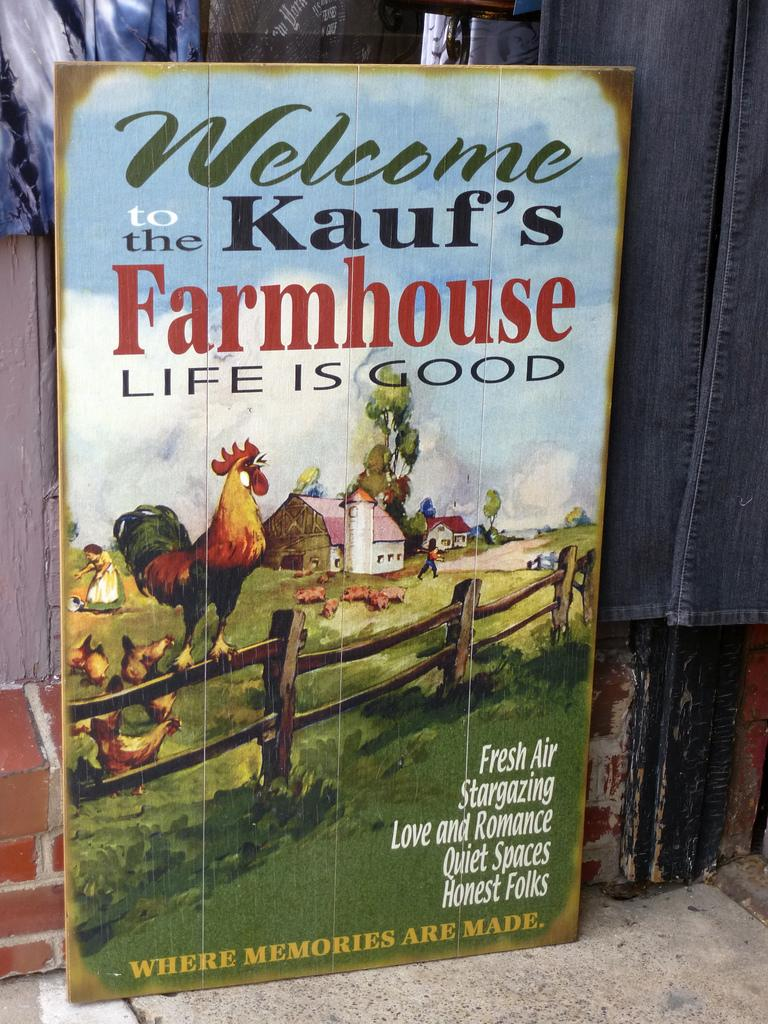What is the main object in the image? There is a display board in the image. What can be seen on the display board? The display board has text and pictures on it. What is behind the display board? There is a wall behind the display board. What type of clothing is visible in the image? Jeans are visible in the image. Where is the minister sitting in the image? There is no minister present in the image. Can you point out the map on the display board? There is no map on the display board; it has text and pictures. 